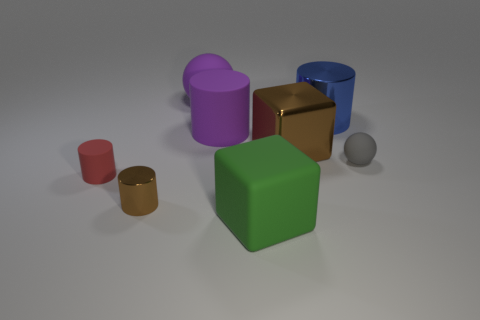Subtract all large matte cylinders. How many cylinders are left? 3 Subtract all green blocks. How many blocks are left? 1 Subtract 1 cylinders. How many cylinders are left? 3 Add 1 small yellow shiny cylinders. How many objects exist? 9 Subtract all cyan blocks. Subtract all cyan spheres. How many blocks are left? 2 Subtract all red blocks. How many gray cylinders are left? 0 Subtract all spheres. How many objects are left? 6 Subtract all small gray metal cubes. Subtract all metallic cylinders. How many objects are left? 6 Add 1 brown cylinders. How many brown cylinders are left? 2 Add 8 purple metal balls. How many purple metal balls exist? 8 